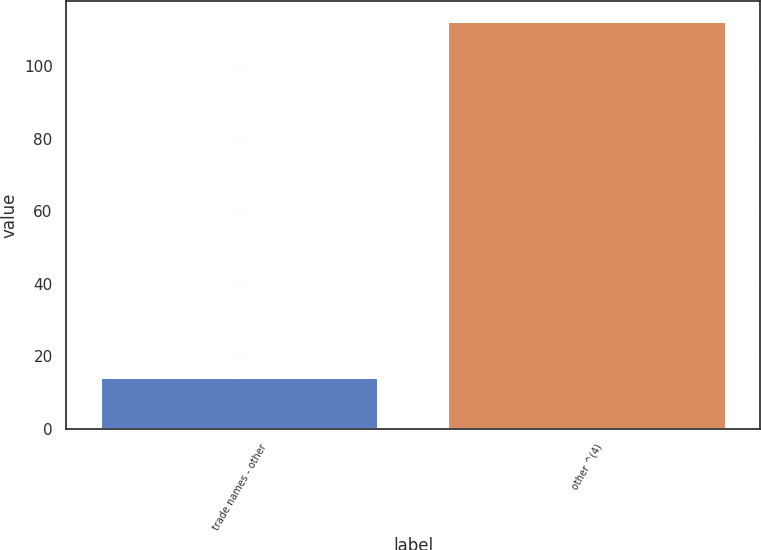Convert chart. <chart><loc_0><loc_0><loc_500><loc_500><bar_chart><fcel>trade names - other<fcel>other ^(4)<nl><fcel>14.1<fcel>112.3<nl></chart> 